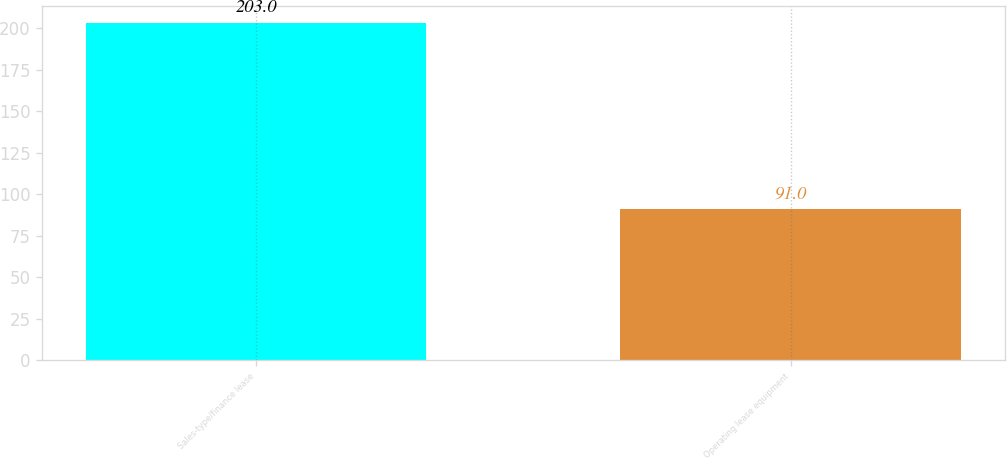Convert chart to OTSL. <chart><loc_0><loc_0><loc_500><loc_500><bar_chart><fcel>Sales-type/finance lease<fcel>Operating lease equipment<nl><fcel>203<fcel>91<nl></chart> 